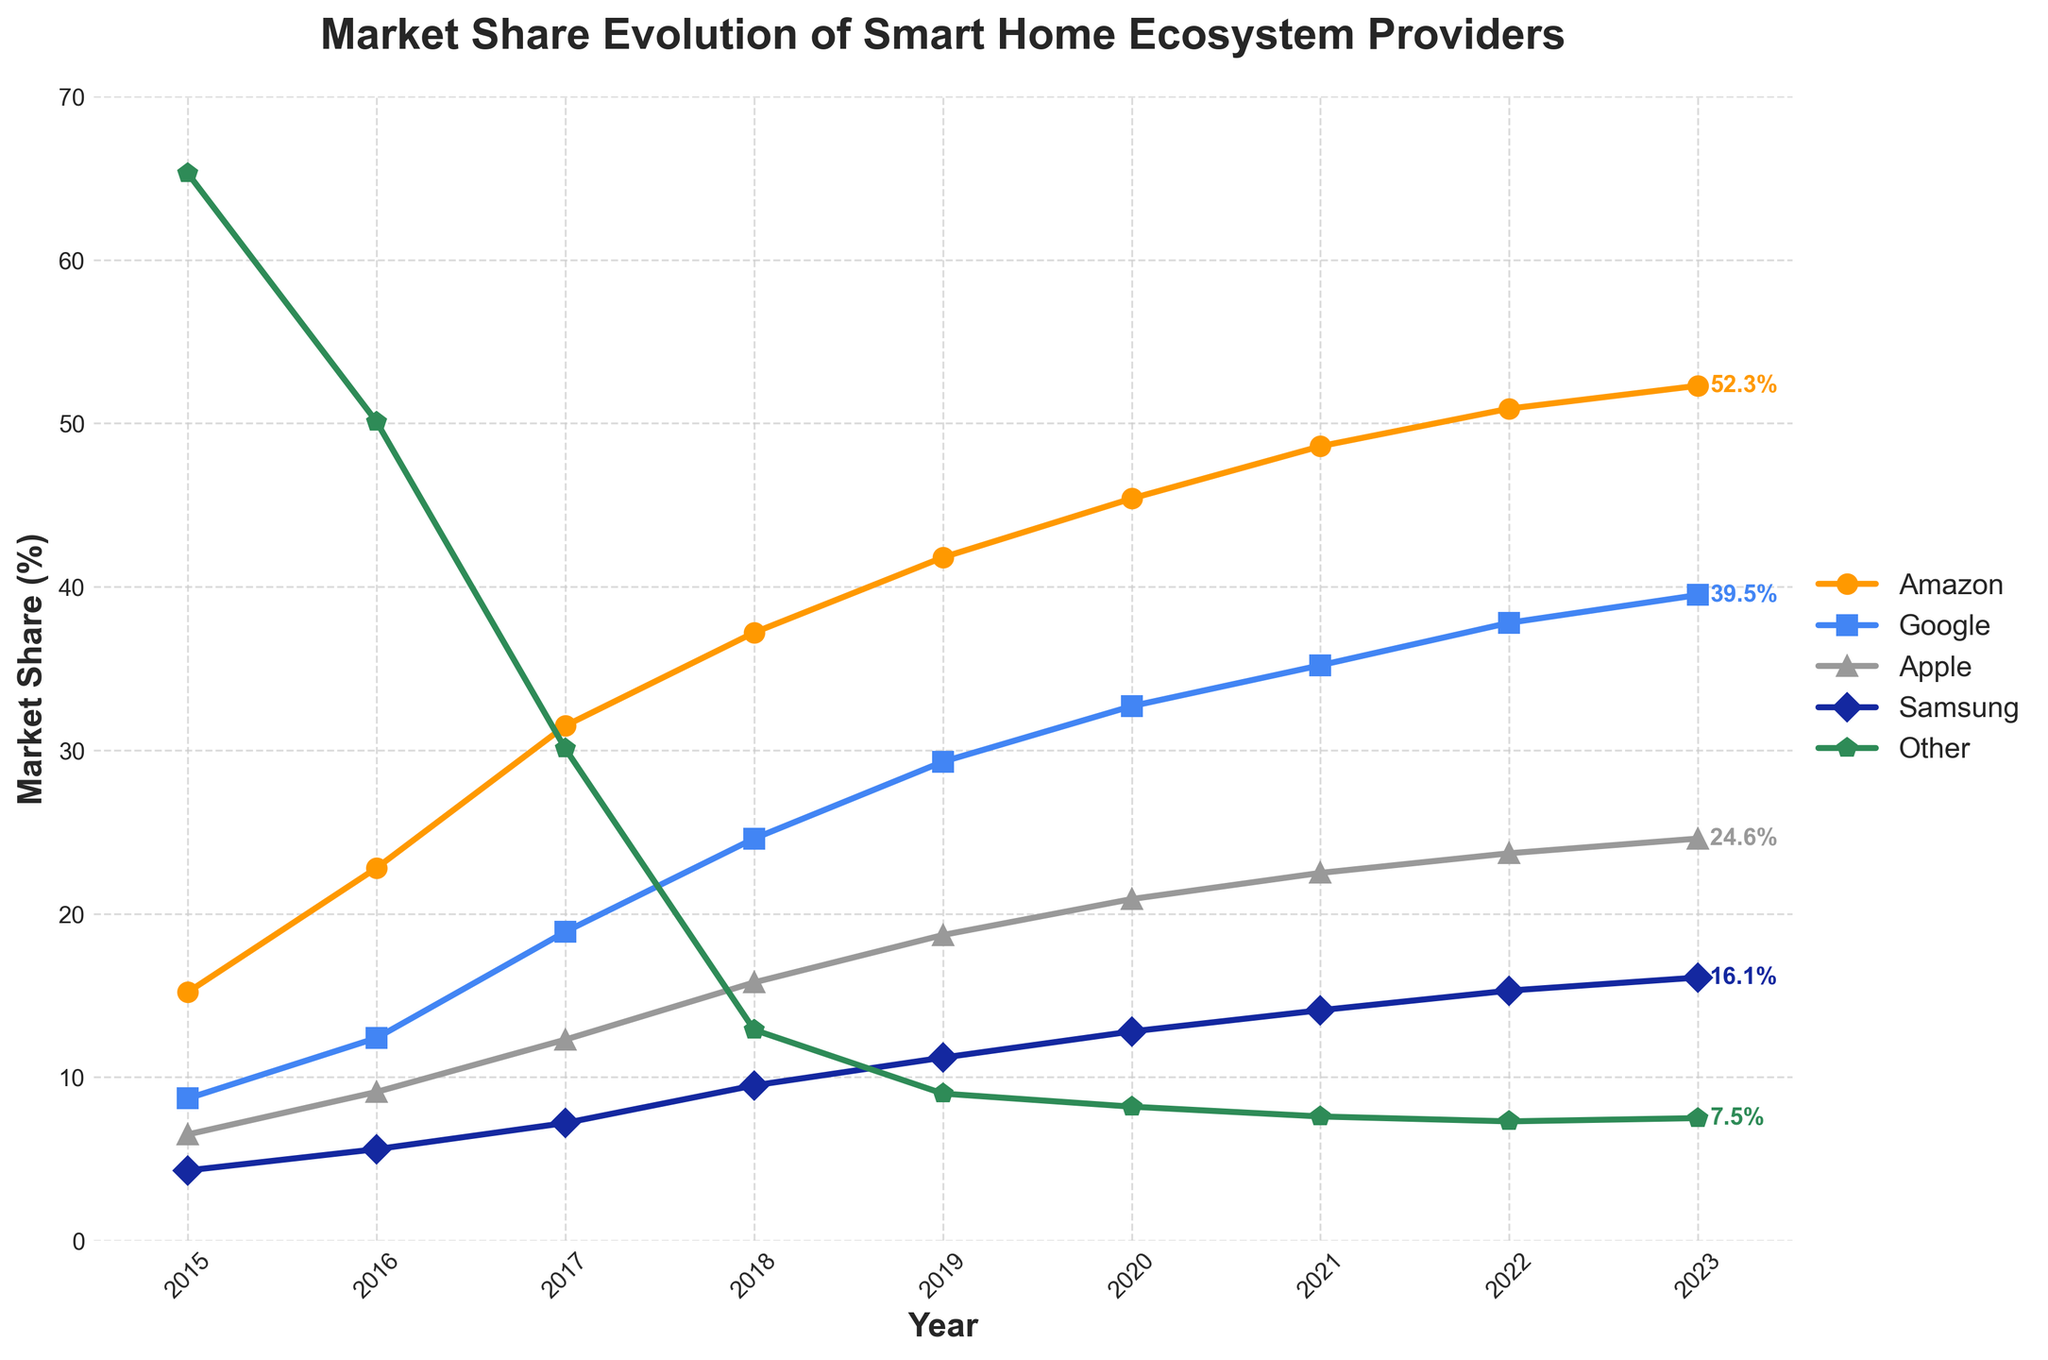When did Amazon surpass 50% market share? According to the chart, the market share of Amazon crossed the 50% threshold in 2022.
Answer: 2022 Which provider had the second-highest market share in 2021? In 2021, Google had the second-highest market share after Amazon, as shown on the chart.
Answer: Google What is the total market share of Apple and Samsung in 2019? In 2019, the market share of Apple was 18.7% and Samsung was 11.2%. Adding these together results in 18.7% + 11.2% = 29.9%.
Answer: 29.9% Did Google's market share increase or decrease between 2022 and 2023? Google's market share increased from 37.8% in 2022 to 39.5% in 2023, as indicated by the upward slope of the line.
Answer: Increase What color represents Samsung in the chart? Samsung is represented by the blue line, as indicated by the color used for its line.
Answer: Blue Between which two consecutive years did Amazon experience the largest increase in market share? Amazon's market share increased the most between 2016 (22.8%) and 2017 (31.5%), a difference of 31.5% - 22.8% = 8.7%.
Answer: 2016 to 2017 How many providers had a market share greater than 20% in 2023? In 2023, Amazon (52.3%), Google (39.5%), and Apple (24.6%) each had a market share greater than 20%. Therefore, three providers exceeded the 20% threshold.
Answer: 3 Which provider had the smallest market share in 2018 and what was it? In 2018, the 'Other' category had the smallest share at 12.9%, as indicated at the end of the line representing 'Other'.
Answer: Other, 12.9% What was the market share of Amazon in the first and last years shown on the chart? In 2015, Amazon's market share was 15.2%, and by 2023, it had risen to 52.3%, as shown on the chart.
Answer: 15.2% and 52.3% 